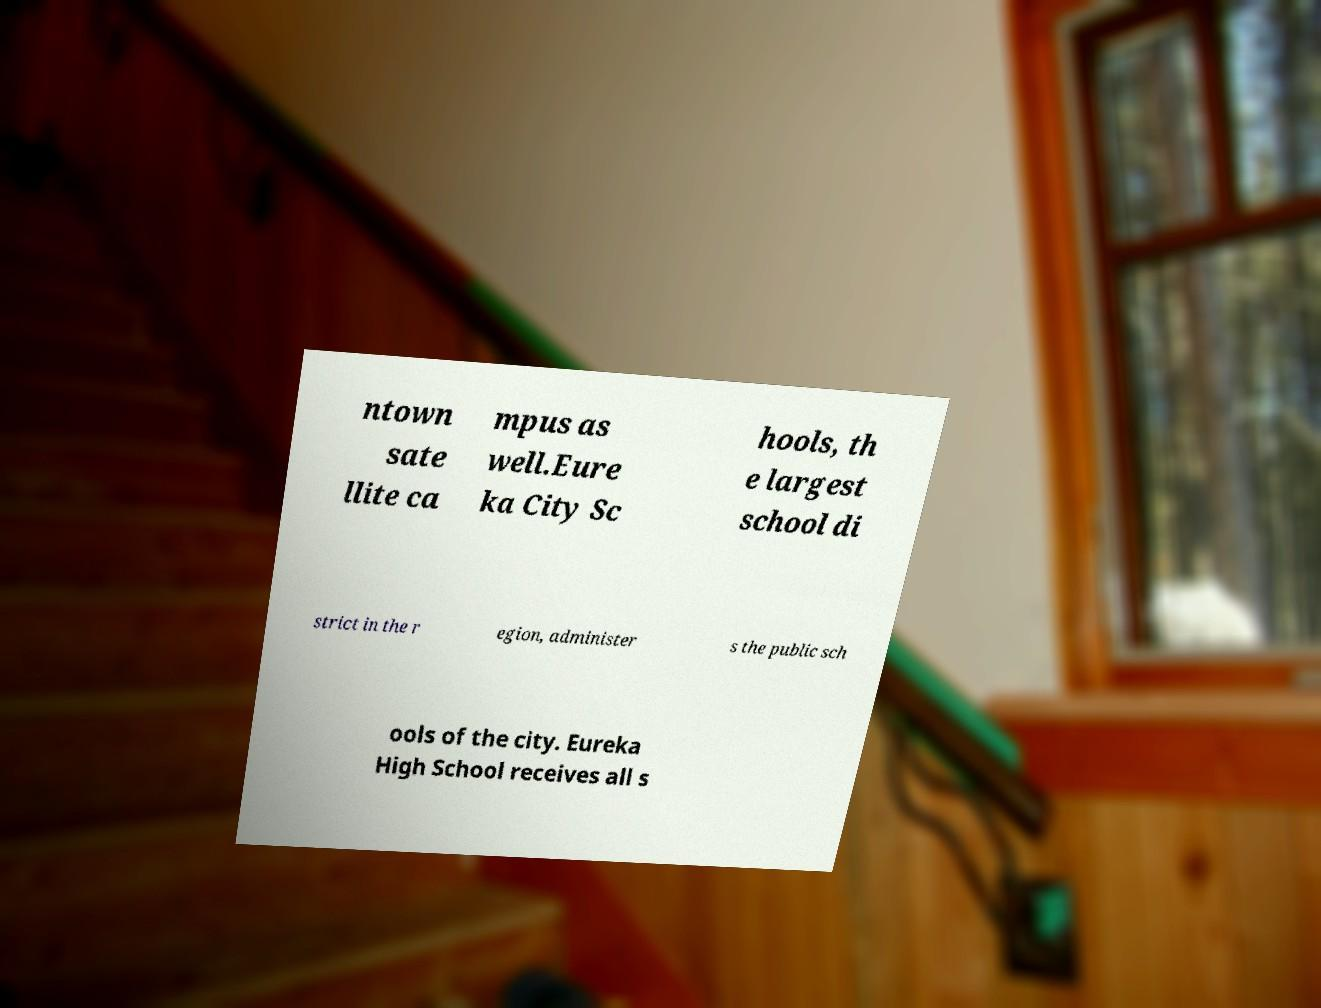Can you read and provide the text displayed in the image?This photo seems to have some interesting text. Can you extract and type it out for me? ntown sate llite ca mpus as well.Eure ka City Sc hools, th e largest school di strict in the r egion, administer s the public sch ools of the city. Eureka High School receives all s 